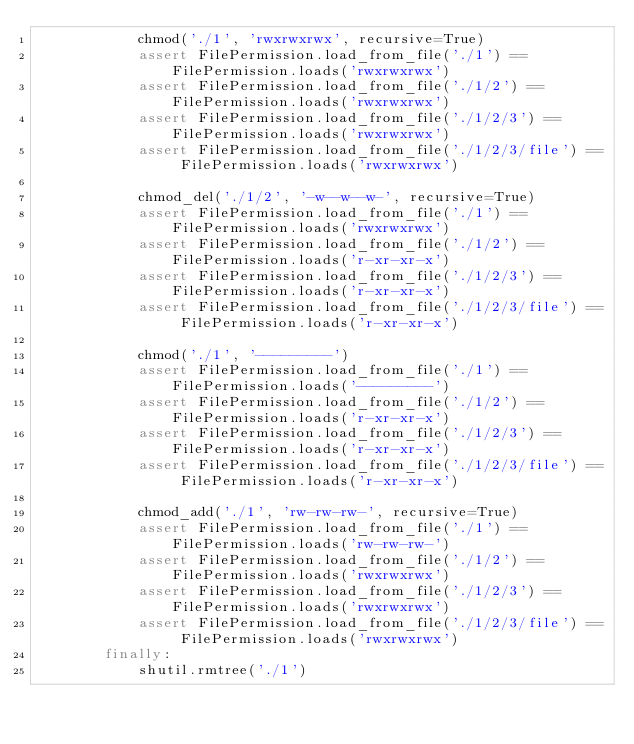Convert code to text. <code><loc_0><loc_0><loc_500><loc_500><_Python_>            chmod('./1', 'rwxrwxrwx', recursive=True)
            assert FilePermission.load_from_file('./1') == FilePermission.loads('rwxrwxrwx')
            assert FilePermission.load_from_file('./1/2') == FilePermission.loads('rwxrwxrwx')
            assert FilePermission.load_from_file('./1/2/3') == FilePermission.loads('rwxrwxrwx')
            assert FilePermission.load_from_file('./1/2/3/file') == FilePermission.loads('rwxrwxrwx')

            chmod_del('./1/2', '-w--w--w-', recursive=True)
            assert FilePermission.load_from_file('./1') == FilePermission.loads('rwxrwxrwx')
            assert FilePermission.load_from_file('./1/2') == FilePermission.loads('r-xr-xr-x')
            assert FilePermission.load_from_file('./1/2/3') == FilePermission.loads('r-xr-xr-x')
            assert FilePermission.load_from_file('./1/2/3/file') == FilePermission.loads('r-xr-xr-x')

            chmod('./1', '---------')
            assert FilePermission.load_from_file('./1') == FilePermission.loads('---------')
            assert FilePermission.load_from_file('./1/2') == FilePermission.loads('r-xr-xr-x')
            assert FilePermission.load_from_file('./1/2/3') == FilePermission.loads('r-xr-xr-x')
            assert FilePermission.load_from_file('./1/2/3/file') == FilePermission.loads('r-xr-xr-x')

            chmod_add('./1', 'rw-rw-rw-', recursive=True)
            assert FilePermission.load_from_file('./1') == FilePermission.loads('rw-rw-rw-')
            assert FilePermission.load_from_file('./1/2') == FilePermission.loads('rwxrwxrwx')
            assert FilePermission.load_from_file('./1/2/3') == FilePermission.loads('rwxrwxrwx')
            assert FilePermission.load_from_file('./1/2/3/file') == FilePermission.loads('rwxrwxrwx')
        finally:
            shutil.rmtree('./1')
</code> 